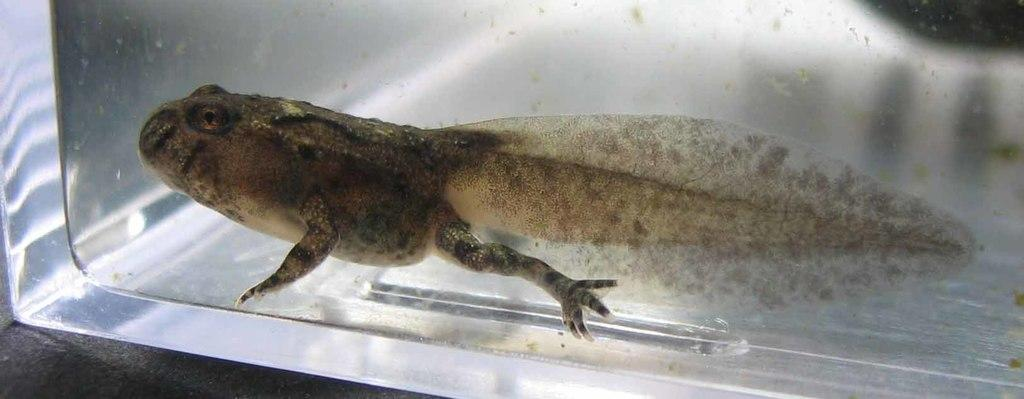What type of animal is present in the image? There is an animal in the image, but the specific type of animal is not mentioned in the facts. Where is the animal located in the image? The animal is inside a box in the image. What is the box placed on in the image? The box is placed on a platform in the image. What type of pickle is the animal holding in the image? There is no pickle present in the image, and the animal is not holding anything. Can you tell me how many drums are visible in the image? There are no drums present in the image. 